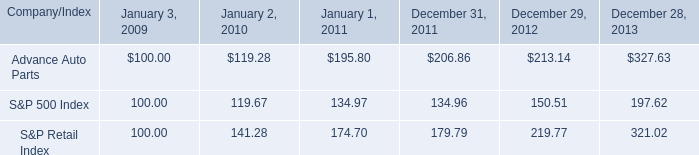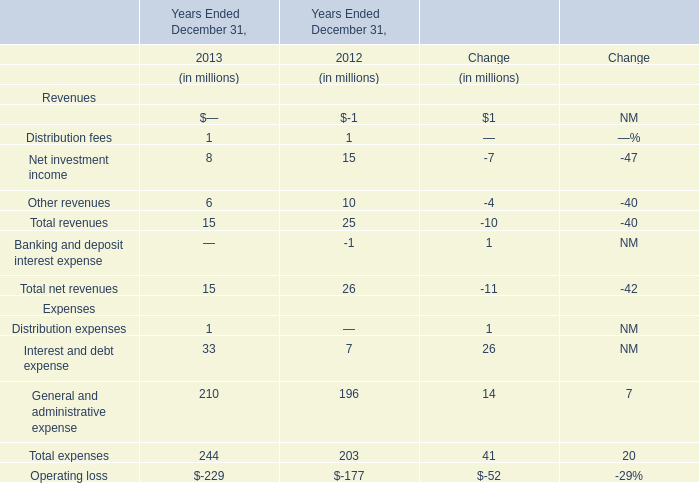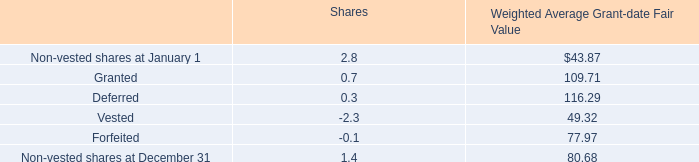What's the growth rate of General and administrative expense in 2013? 
Computations: ((210 - 196) / 196)
Answer: 0.07143. 